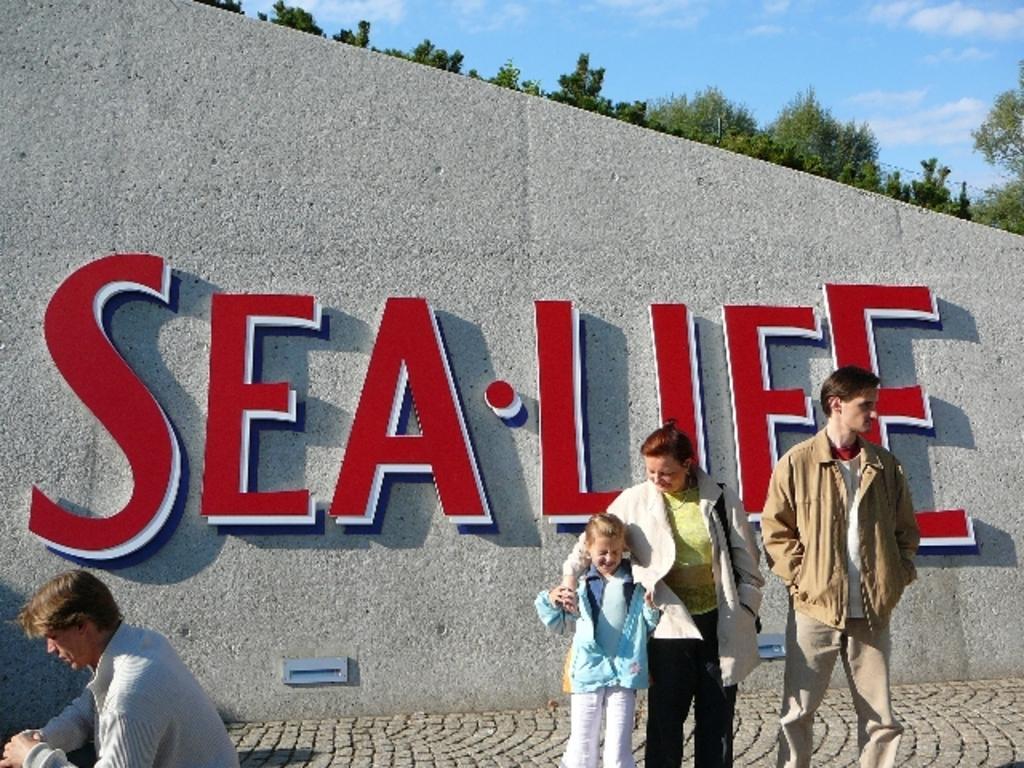How would you summarize this image in a sentence or two? In this picture we can see a group of people standing on a platform, wall with a name on it, trees and in the background we can see the sky with clouds. 